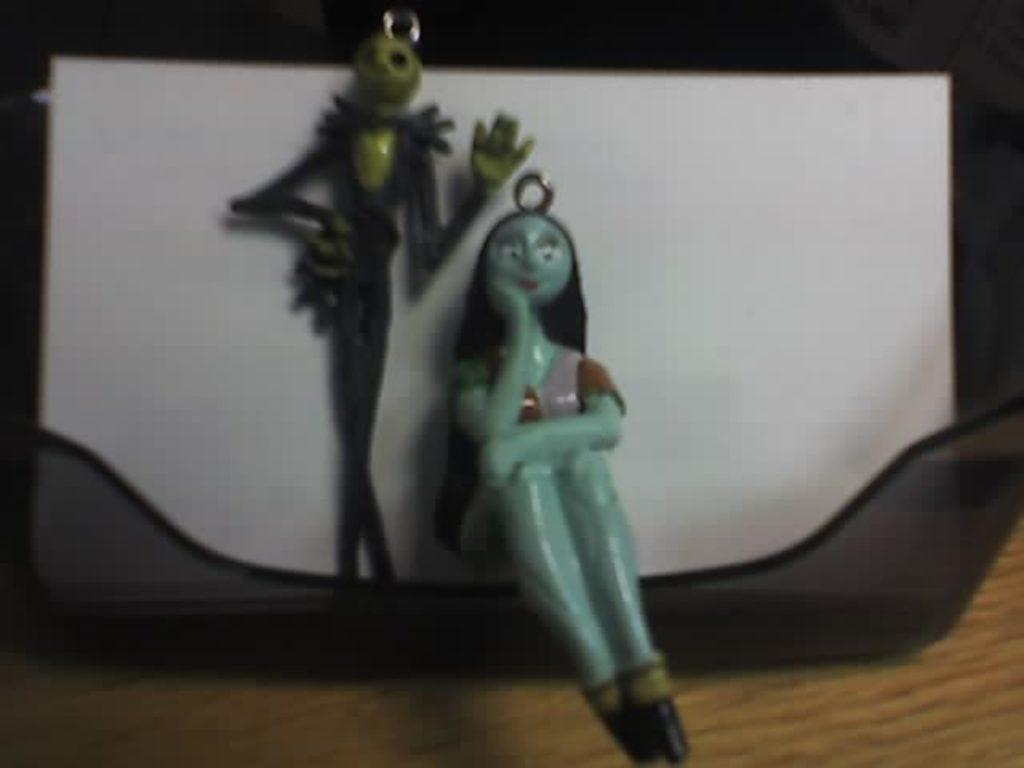What is the main object in the image? There is an object in the image, but the specific object is not mentioned in the facts. What type of material is present in the image? There is paper in the image. How many toys are visible in the image? There are two toys in the image. What is the surface on which the objects are placed? The objects are placed on a wooden surface. What can be said about the lighting in the image? The background of the image is dark. Can you see a goose swimming in the image? There is no goose or swimming activity present in the image. 